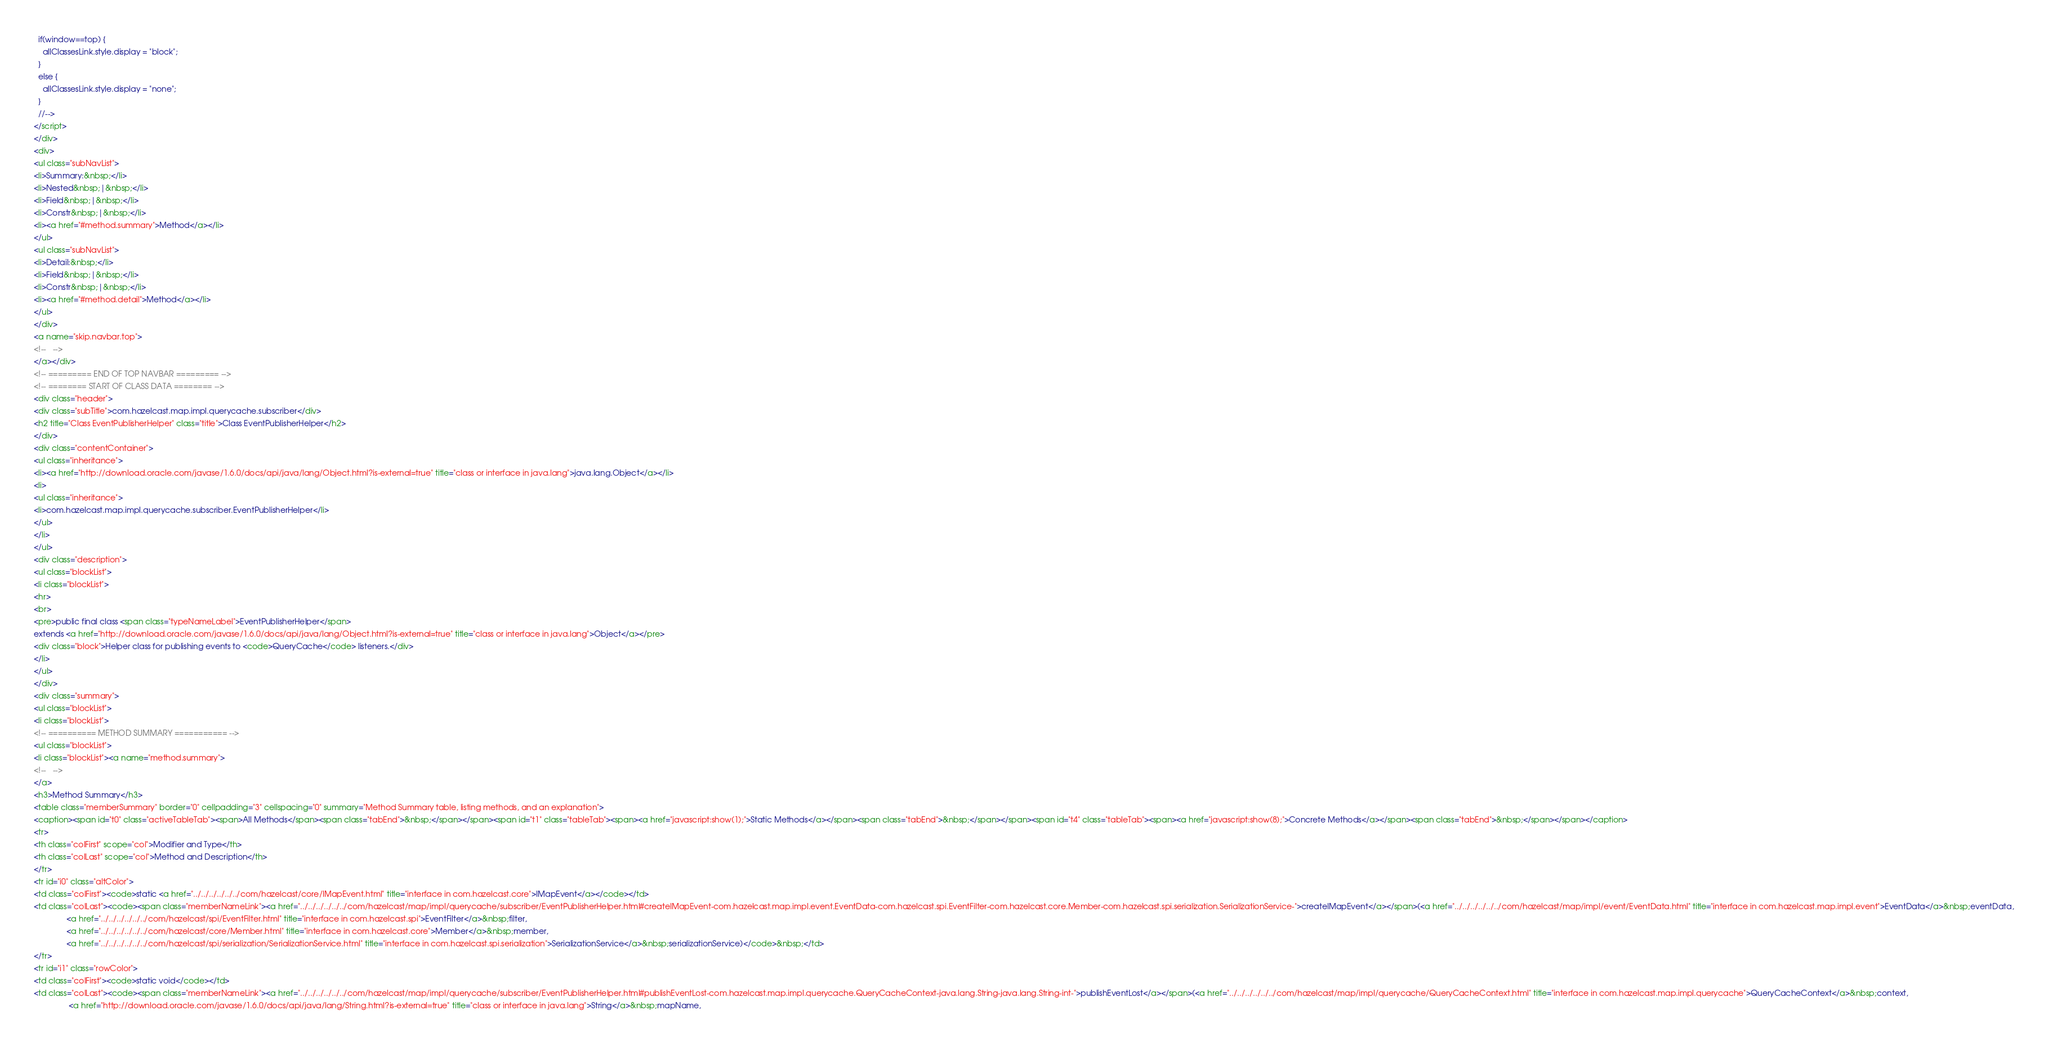<code> <loc_0><loc_0><loc_500><loc_500><_HTML_>  if(window==top) {
    allClassesLink.style.display = "block";
  }
  else {
    allClassesLink.style.display = "none";
  }
  //-->
</script>
</div>
<div>
<ul class="subNavList">
<li>Summary:&nbsp;</li>
<li>Nested&nbsp;|&nbsp;</li>
<li>Field&nbsp;|&nbsp;</li>
<li>Constr&nbsp;|&nbsp;</li>
<li><a href="#method.summary">Method</a></li>
</ul>
<ul class="subNavList">
<li>Detail:&nbsp;</li>
<li>Field&nbsp;|&nbsp;</li>
<li>Constr&nbsp;|&nbsp;</li>
<li><a href="#method.detail">Method</a></li>
</ul>
</div>
<a name="skip.navbar.top">
<!--   -->
</a></div>
<!-- ========= END OF TOP NAVBAR ========= -->
<!-- ======== START OF CLASS DATA ======== -->
<div class="header">
<div class="subTitle">com.hazelcast.map.impl.querycache.subscriber</div>
<h2 title="Class EventPublisherHelper" class="title">Class EventPublisherHelper</h2>
</div>
<div class="contentContainer">
<ul class="inheritance">
<li><a href="http://download.oracle.com/javase/1.6.0/docs/api/java/lang/Object.html?is-external=true" title="class or interface in java.lang">java.lang.Object</a></li>
<li>
<ul class="inheritance">
<li>com.hazelcast.map.impl.querycache.subscriber.EventPublisherHelper</li>
</ul>
</li>
</ul>
<div class="description">
<ul class="blockList">
<li class="blockList">
<hr>
<br>
<pre>public final class <span class="typeNameLabel">EventPublisherHelper</span>
extends <a href="http://download.oracle.com/javase/1.6.0/docs/api/java/lang/Object.html?is-external=true" title="class or interface in java.lang">Object</a></pre>
<div class="block">Helper class for publishing events to <code>QueryCache</code> listeners.</div>
</li>
</ul>
</div>
<div class="summary">
<ul class="blockList">
<li class="blockList">
<!-- ========== METHOD SUMMARY =========== -->
<ul class="blockList">
<li class="blockList"><a name="method.summary">
<!--   -->
</a>
<h3>Method Summary</h3>
<table class="memberSummary" border="0" cellpadding="3" cellspacing="0" summary="Method Summary table, listing methods, and an explanation">
<caption><span id="t0" class="activeTableTab"><span>All Methods</span><span class="tabEnd">&nbsp;</span></span><span id="t1" class="tableTab"><span><a href="javascript:show(1);">Static Methods</a></span><span class="tabEnd">&nbsp;</span></span><span id="t4" class="tableTab"><span><a href="javascript:show(8);">Concrete Methods</a></span><span class="tabEnd">&nbsp;</span></span></caption>
<tr>
<th class="colFirst" scope="col">Modifier and Type</th>
<th class="colLast" scope="col">Method and Description</th>
</tr>
<tr id="i0" class="altColor">
<td class="colFirst"><code>static <a href="../../../../../../com/hazelcast/core/IMapEvent.html" title="interface in com.hazelcast.core">IMapEvent</a></code></td>
<td class="colLast"><code><span class="memberNameLink"><a href="../../../../../../com/hazelcast/map/impl/querycache/subscriber/EventPublisherHelper.html#createIMapEvent-com.hazelcast.map.impl.event.EventData-com.hazelcast.spi.EventFilter-com.hazelcast.core.Member-com.hazelcast.spi.serialization.SerializationService-">createIMapEvent</a></span>(<a href="../../../../../../com/hazelcast/map/impl/event/EventData.html" title="interface in com.hazelcast.map.impl.event">EventData</a>&nbsp;eventData,
               <a href="../../../../../../com/hazelcast/spi/EventFilter.html" title="interface in com.hazelcast.spi">EventFilter</a>&nbsp;filter,
               <a href="../../../../../../com/hazelcast/core/Member.html" title="interface in com.hazelcast.core">Member</a>&nbsp;member,
               <a href="../../../../../../com/hazelcast/spi/serialization/SerializationService.html" title="interface in com.hazelcast.spi.serialization">SerializationService</a>&nbsp;serializationService)</code>&nbsp;</td>
</tr>
<tr id="i1" class="rowColor">
<td class="colFirst"><code>static void</code></td>
<td class="colLast"><code><span class="memberNameLink"><a href="../../../../../../com/hazelcast/map/impl/querycache/subscriber/EventPublisherHelper.html#publishEventLost-com.hazelcast.map.impl.querycache.QueryCacheContext-java.lang.String-java.lang.String-int-">publishEventLost</a></span>(<a href="../../../../../../com/hazelcast/map/impl/querycache/QueryCacheContext.html" title="interface in com.hazelcast.map.impl.querycache">QueryCacheContext</a>&nbsp;context,
                <a href="http://download.oracle.com/javase/1.6.0/docs/api/java/lang/String.html?is-external=true" title="class or interface in java.lang">String</a>&nbsp;mapName,</code> 